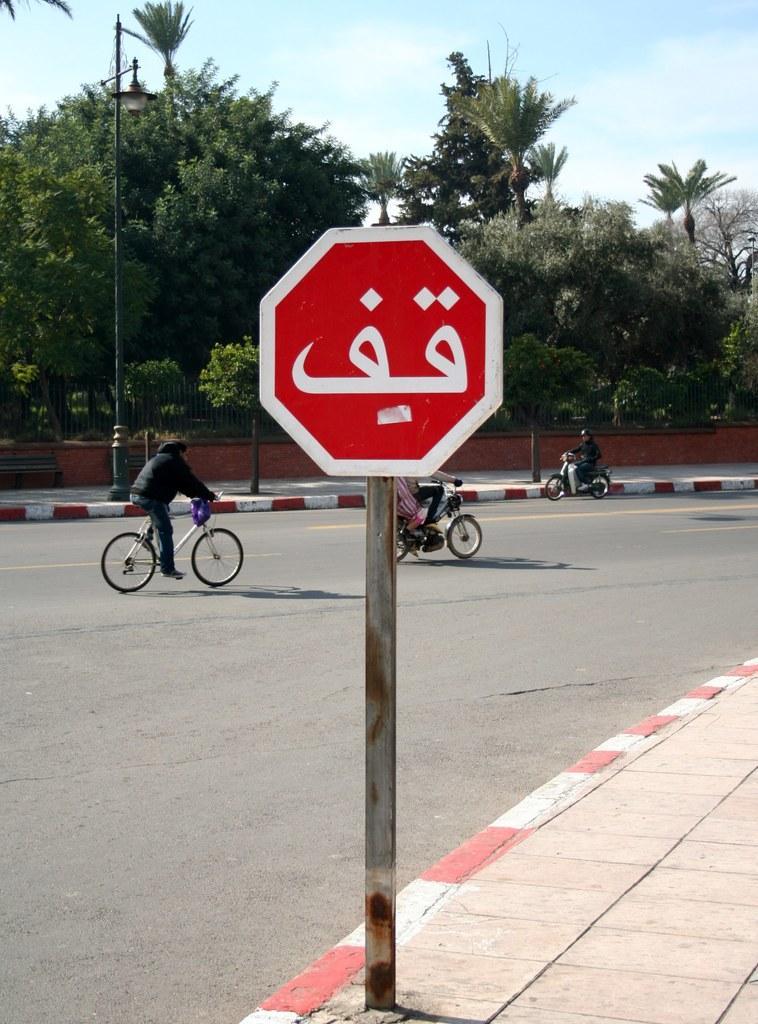Please provide a concise description of this image. In this image I can see a board, light poles, three persons are riding bikes on the road, fence, trees and the sky. This image is taken may be during a day. 